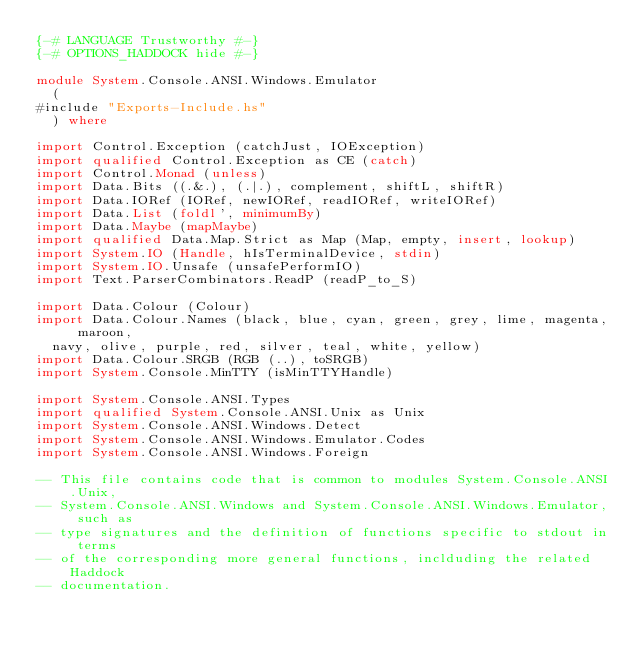Convert code to text. <code><loc_0><loc_0><loc_500><loc_500><_Haskell_>{-# LANGUAGE Trustworthy #-}
{-# OPTIONS_HADDOCK hide #-}

module System.Console.ANSI.Windows.Emulator
  (
#include "Exports-Include.hs"
  ) where

import Control.Exception (catchJust, IOException)
import qualified Control.Exception as CE (catch)
import Control.Monad (unless)
import Data.Bits ((.&.), (.|.), complement, shiftL, shiftR)
import Data.IORef (IORef, newIORef, readIORef, writeIORef)
import Data.List (foldl', minimumBy)
import Data.Maybe (mapMaybe)
import qualified Data.Map.Strict as Map (Map, empty, insert, lookup)
import System.IO (Handle, hIsTerminalDevice, stdin)
import System.IO.Unsafe (unsafePerformIO)
import Text.ParserCombinators.ReadP (readP_to_S)

import Data.Colour (Colour)
import Data.Colour.Names (black, blue, cyan, green, grey, lime, magenta, maroon,
  navy, olive, purple, red, silver, teal, white, yellow)
import Data.Colour.SRGB (RGB (..), toSRGB)
import System.Console.MinTTY (isMinTTYHandle)

import System.Console.ANSI.Types
import qualified System.Console.ANSI.Unix as Unix
import System.Console.ANSI.Windows.Detect
import System.Console.ANSI.Windows.Emulator.Codes
import System.Console.ANSI.Windows.Foreign

-- This file contains code that is common to modules System.Console.ANSI.Unix,
-- System.Console.ANSI.Windows and System.Console.ANSI.Windows.Emulator, such as
-- type signatures and the definition of functions specific to stdout in terms
-- of the corresponding more general functions, inclduding the related Haddock
-- documentation.</code> 